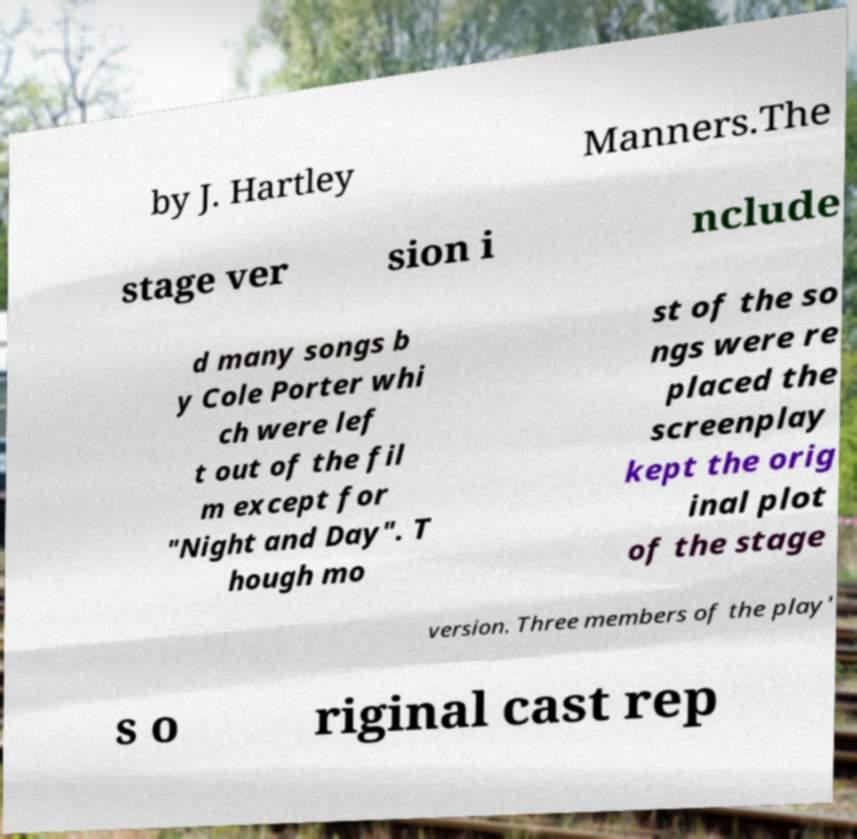For documentation purposes, I need the text within this image transcribed. Could you provide that? by J. Hartley Manners.The stage ver sion i nclude d many songs b y Cole Porter whi ch were lef t out of the fil m except for "Night and Day". T hough mo st of the so ngs were re placed the screenplay kept the orig inal plot of the stage version. Three members of the play' s o riginal cast rep 